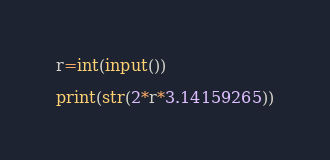<code> <loc_0><loc_0><loc_500><loc_500><_Python_>r=int(input())

print(str(2*r*3.14159265))</code> 